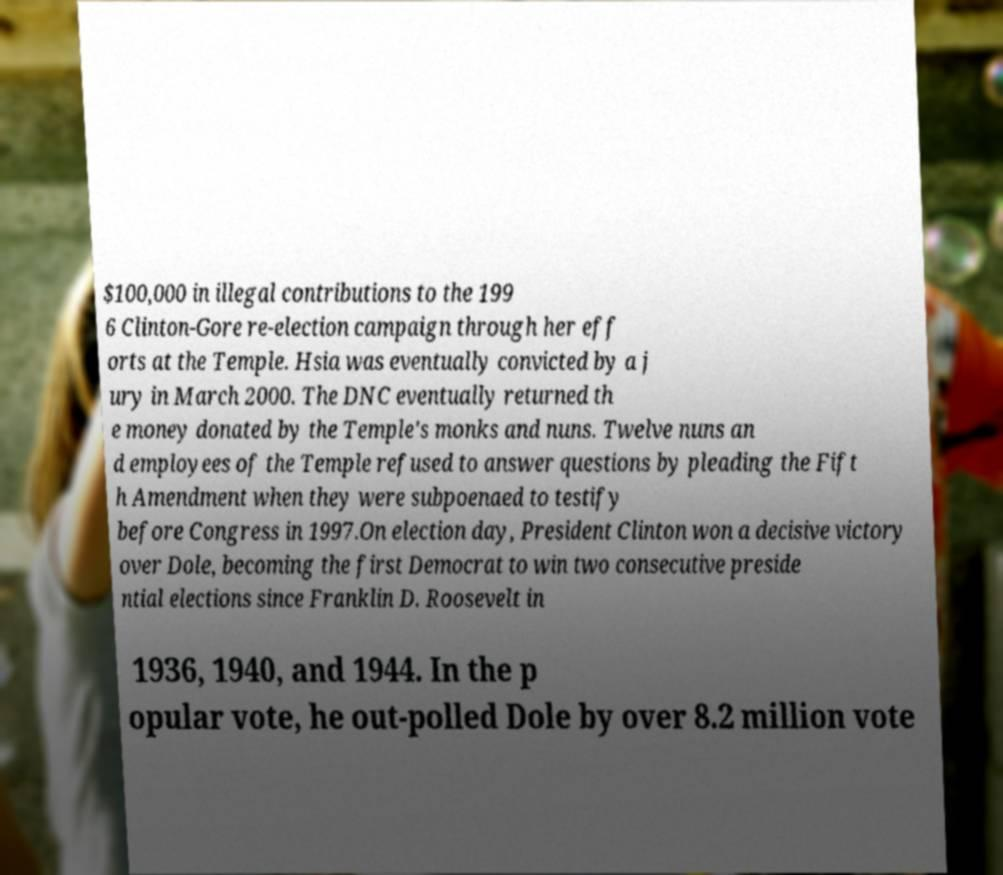Could you extract and type out the text from this image? $100,000 in illegal contributions to the 199 6 Clinton-Gore re-election campaign through her eff orts at the Temple. Hsia was eventually convicted by a j ury in March 2000. The DNC eventually returned th e money donated by the Temple's monks and nuns. Twelve nuns an d employees of the Temple refused to answer questions by pleading the Fift h Amendment when they were subpoenaed to testify before Congress in 1997.On election day, President Clinton won a decisive victory over Dole, becoming the first Democrat to win two consecutive preside ntial elections since Franklin D. Roosevelt in 1936, 1940, and 1944. In the p opular vote, he out-polled Dole by over 8.2 million vote 